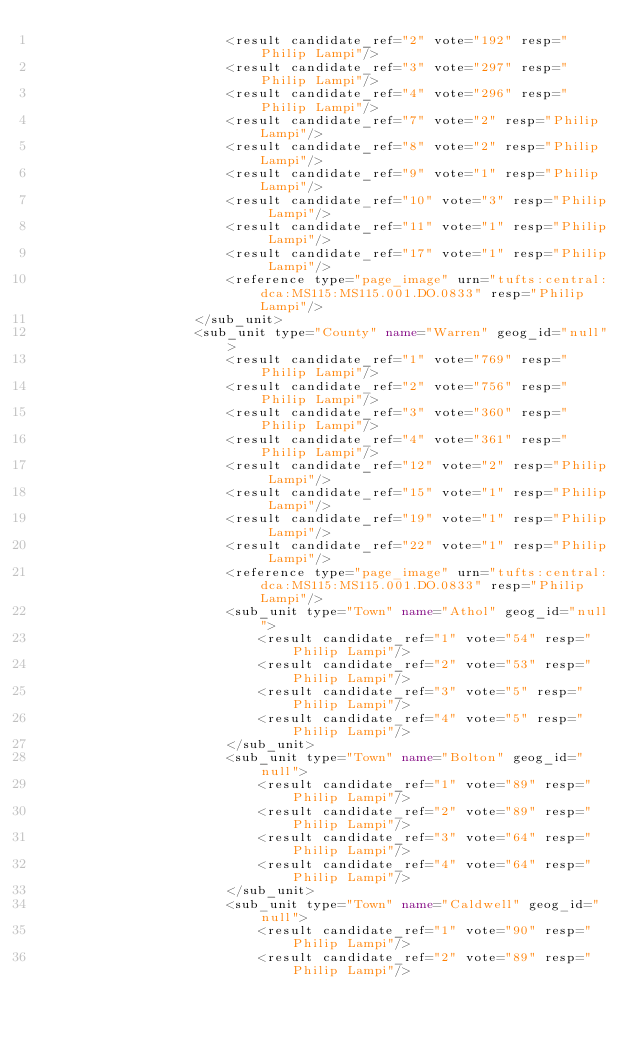Convert code to text. <code><loc_0><loc_0><loc_500><loc_500><_XML_>						<result candidate_ref="2" vote="192" resp="Philip Lampi"/>
						<result candidate_ref="3" vote="297" resp="Philip Lampi"/>
						<result candidate_ref="4" vote="296" resp="Philip Lampi"/>
						<result candidate_ref="7" vote="2" resp="Philip Lampi"/>
						<result candidate_ref="8" vote="2" resp="Philip Lampi"/>
						<result candidate_ref="9" vote="1" resp="Philip Lampi"/>
						<result candidate_ref="10" vote="3" resp="Philip Lampi"/>
						<result candidate_ref="11" vote="1" resp="Philip Lampi"/>
						<result candidate_ref="17" vote="1" resp="Philip Lampi"/>
						<reference type="page_image" urn="tufts:central:dca:MS115:MS115.001.DO.0833" resp="Philip Lampi"/>
					</sub_unit>
					<sub_unit type="County" name="Warren" geog_id="null">
						<result candidate_ref="1" vote="769" resp="Philip Lampi"/>
						<result candidate_ref="2" vote="756" resp="Philip Lampi"/>
						<result candidate_ref="3" vote="360" resp="Philip Lampi"/>
						<result candidate_ref="4" vote="361" resp="Philip Lampi"/>
						<result candidate_ref="12" vote="2" resp="Philip Lampi"/>
						<result candidate_ref="15" vote="1" resp="Philip Lampi"/>
						<result candidate_ref="19" vote="1" resp="Philip Lampi"/>
						<result candidate_ref="22" vote="1" resp="Philip Lampi"/>
						<reference type="page_image" urn="tufts:central:dca:MS115:MS115.001.DO.0833" resp="Philip Lampi"/>
						<sub_unit type="Town" name="Athol" geog_id="null">
							<result candidate_ref="1" vote="54" resp="Philip Lampi"/>
							<result candidate_ref="2" vote="53" resp="Philip Lampi"/>
							<result candidate_ref="3" vote="5" resp="Philip Lampi"/>
							<result candidate_ref="4" vote="5" resp="Philip Lampi"/>
						</sub_unit>
						<sub_unit type="Town" name="Bolton" geog_id="null">
							<result candidate_ref="1" vote="89" resp="Philip Lampi"/>
							<result candidate_ref="2" vote="89" resp="Philip Lampi"/>
							<result candidate_ref="3" vote="64" resp="Philip Lampi"/>
							<result candidate_ref="4" vote="64" resp="Philip Lampi"/>
						</sub_unit>
						<sub_unit type="Town" name="Caldwell" geog_id="null">
							<result candidate_ref="1" vote="90" resp="Philip Lampi"/>
							<result candidate_ref="2" vote="89" resp="Philip Lampi"/></code> 